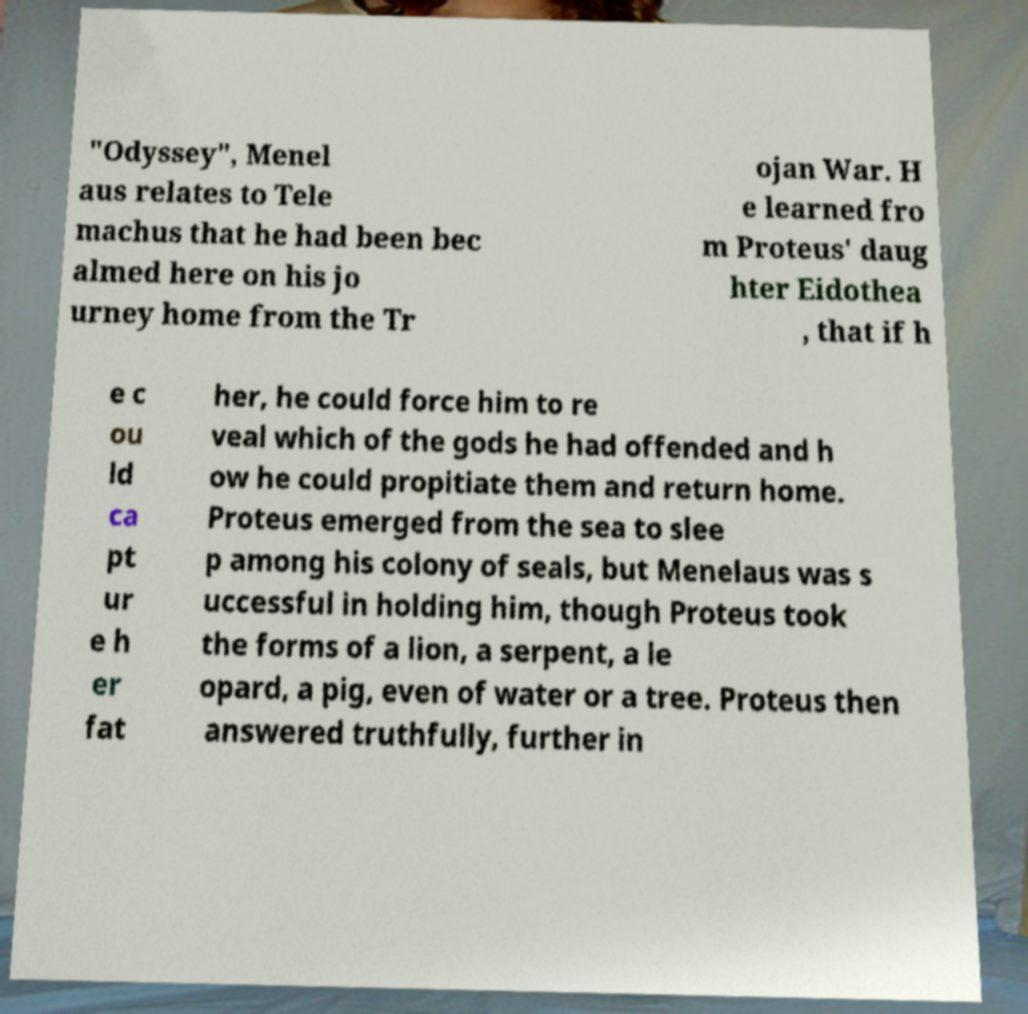What messages or text are displayed in this image? I need them in a readable, typed format. "Odyssey", Menel aus relates to Tele machus that he had been bec almed here on his jo urney home from the Tr ojan War. H e learned fro m Proteus' daug hter Eidothea , that if h e c ou ld ca pt ur e h er fat her, he could force him to re veal which of the gods he had offended and h ow he could propitiate them and return home. Proteus emerged from the sea to slee p among his colony of seals, but Menelaus was s uccessful in holding him, though Proteus took the forms of a lion, a serpent, a le opard, a pig, even of water or a tree. Proteus then answered truthfully, further in 